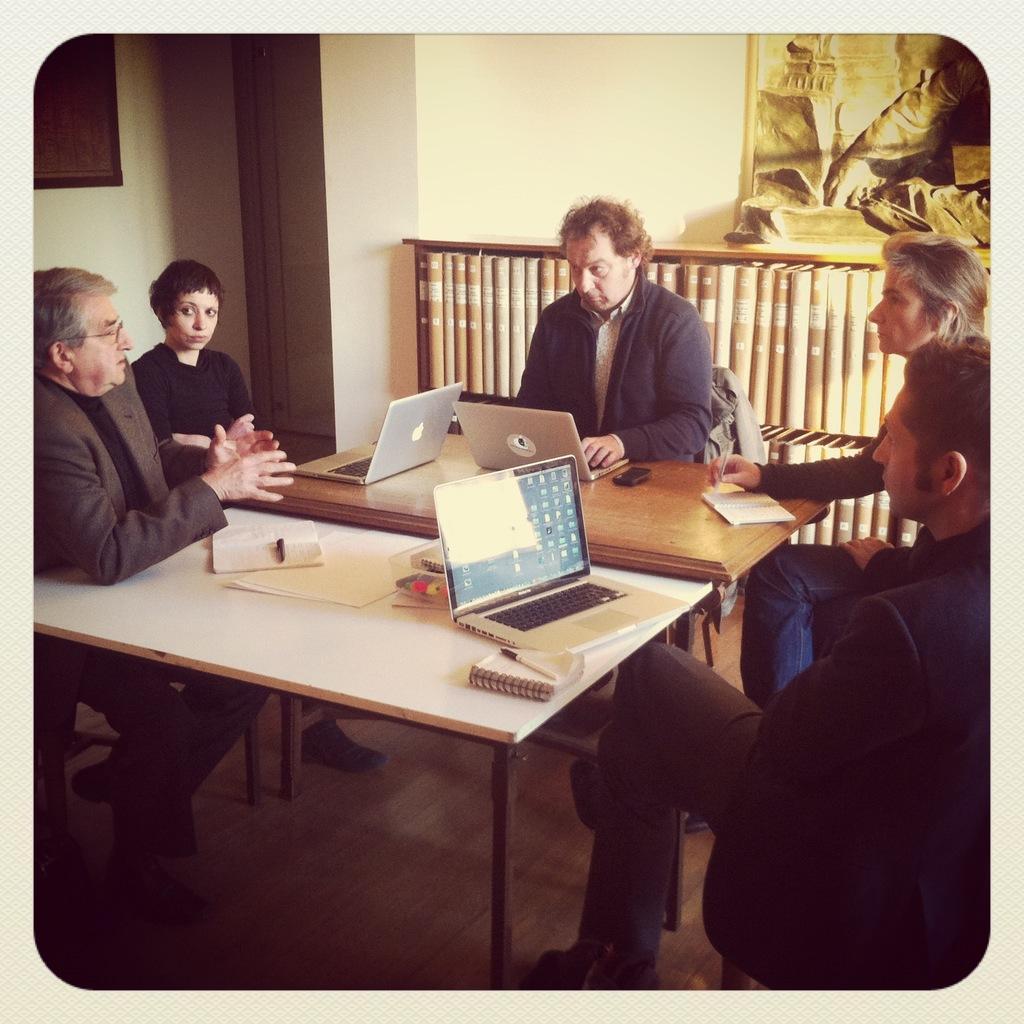Describe this image in one or two sentences. In this image i can see there are the five persons sitting around the table ,on the table there are laptop ,book ,pen visible and there is a fence back side of them and there is a photo frame attached to the wall. 